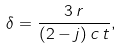<formula> <loc_0><loc_0><loc_500><loc_500>\delta = \frac { 3 \, r } { ( 2 - j ) \, c \, t } ,</formula> 